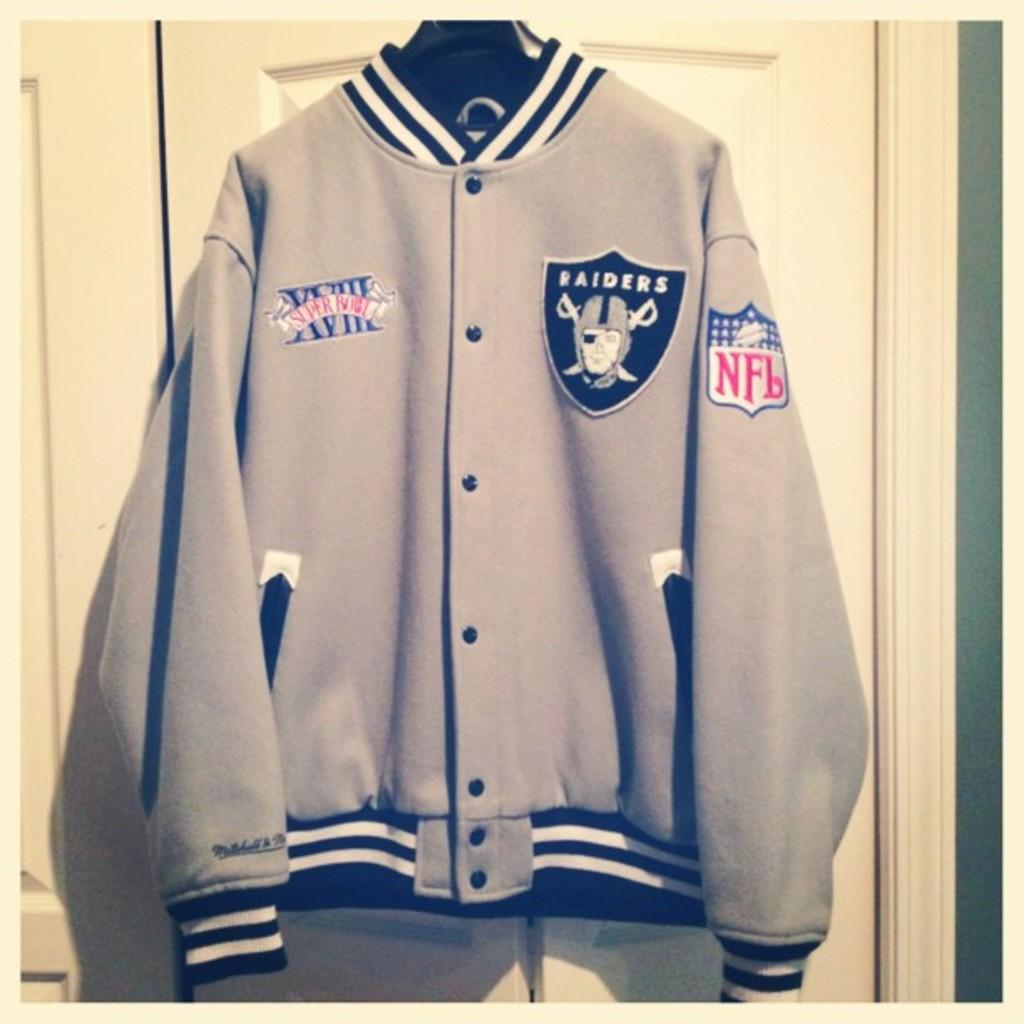<image>
Summarize the visual content of the image. A gray and black Raiders NFL Superbowl XVIII jacket hangs on a door. 